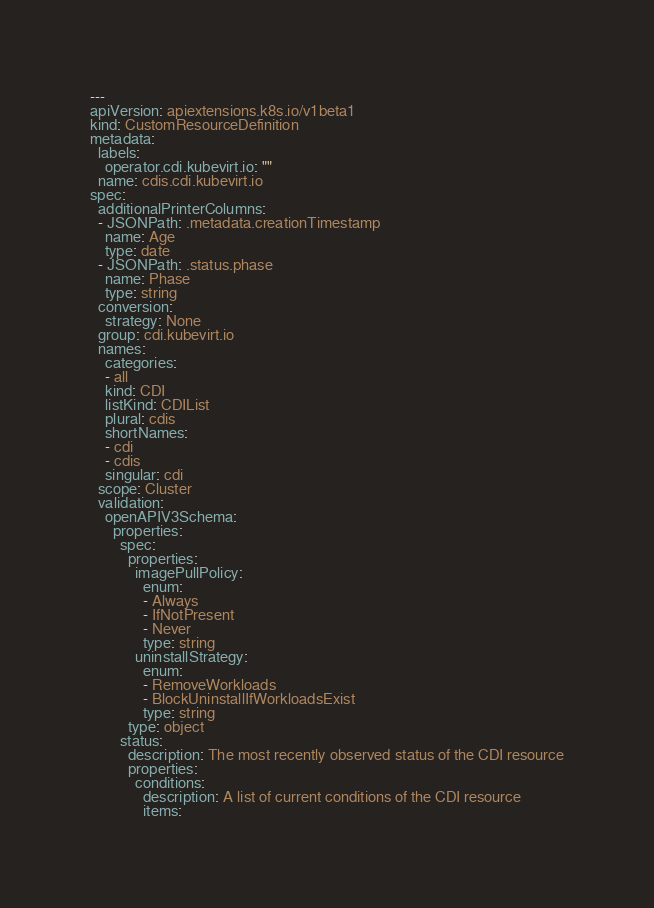<code> <loc_0><loc_0><loc_500><loc_500><_YAML_>---
apiVersion: apiextensions.k8s.io/v1beta1
kind: CustomResourceDefinition
metadata:
  labels:
    operator.cdi.kubevirt.io: ""
  name: cdis.cdi.kubevirt.io
spec:
  additionalPrinterColumns:
  - JSONPath: .metadata.creationTimestamp
    name: Age
    type: date
  - JSONPath: .status.phase
    name: Phase
    type: string
  conversion:
    strategy: None
  group: cdi.kubevirt.io
  names:
    categories:
    - all
    kind: CDI
    listKind: CDIList
    plural: cdis
    shortNames:
    - cdi
    - cdis
    singular: cdi
  scope: Cluster
  validation:
    openAPIV3Schema:
      properties:
        spec:
          properties:
            imagePullPolicy:
              enum:
              - Always
              - IfNotPresent
              - Never
              type: string
            uninstallStrategy:
              enum:
              - RemoveWorkloads
              - BlockUninstallIfWorkloadsExist
              type: string
          type: object
        status:
          description: The most recently observed status of the CDI resource
          properties:
            conditions:
              description: A list of current conditions of the CDI resource
              items:</code> 